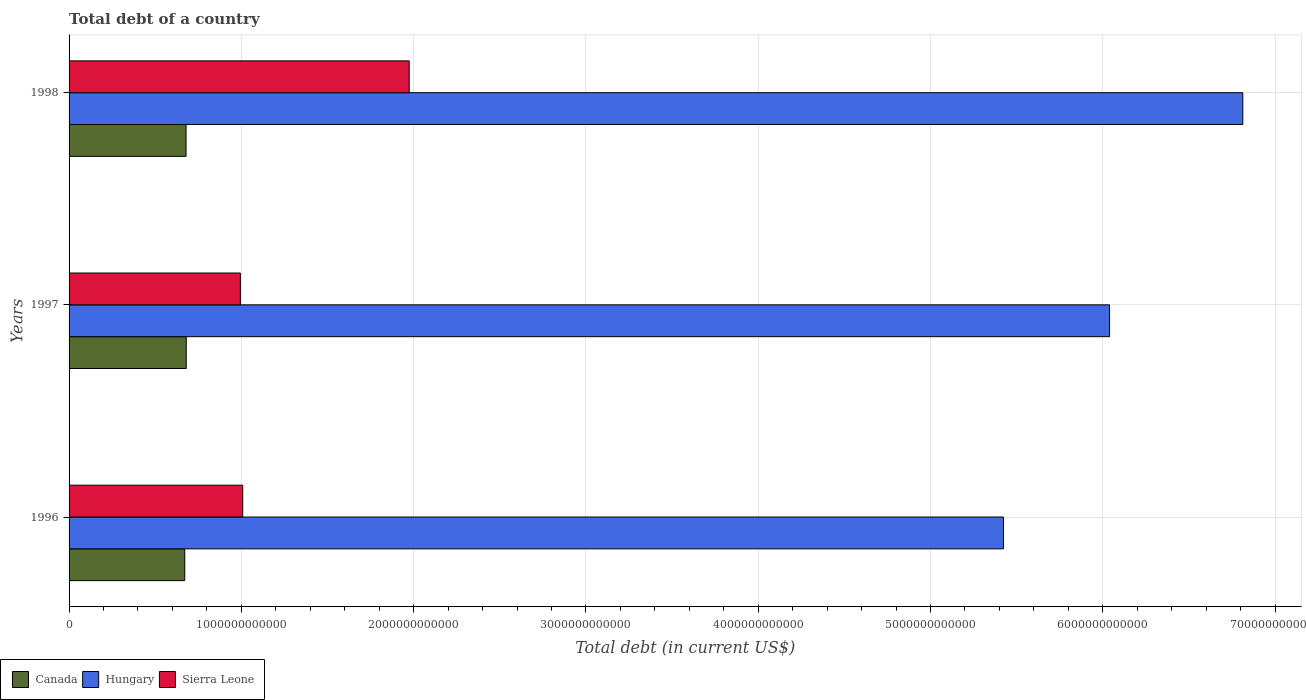How many different coloured bars are there?
Offer a very short reply. 3. Are the number of bars on each tick of the Y-axis equal?
Provide a short and direct response. Yes. How many bars are there on the 2nd tick from the top?
Your answer should be compact. 3. How many bars are there on the 1st tick from the bottom?
Provide a short and direct response. 3. What is the debt in Canada in 1996?
Provide a short and direct response. 6.71e+11. Across all years, what is the maximum debt in Hungary?
Make the answer very short. 6.81e+12. Across all years, what is the minimum debt in Hungary?
Offer a terse response. 5.42e+12. What is the total debt in Canada in the graph?
Make the answer very short. 2.03e+12. What is the difference between the debt in Canada in 1996 and that in 1997?
Provide a succinct answer. -8.71e+09. What is the difference between the debt in Sierra Leone in 1997 and the debt in Canada in 1998?
Keep it short and to the point. 3.15e+11. What is the average debt in Canada per year?
Offer a very short reply. 6.77e+11. In the year 1998, what is the difference between the debt in Canada and debt in Hungary?
Provide a succinct answer. -6.13e+12. What is the ratio of the debt in Hungary in 1996 to that in 1997?
Your answer should be very brief. 0.9. What is the difference between the highest and the second highest debt in Hungary?
Your response must be concise. 7.73e+11. What is the difference between the highest and the lowest debt in Canada?
Your answer should be compact. 8.71e+09. Is the sum of the debt in Hungary in 1996 and 1997 greater than the maximum debt in Canada across all years?
Your answer should be very brief. Yes. What does the 1st bar from the bottom in 1997 represents?
Ensure brevity in your answer.  Canada. How many bars are there?
Make the answer very short. 9. How many years are there in the graph?
Keep it short and to the point. 3. What is the difference between two consecutive major ticks on the X-axis?
Provide a succinct answer. 1.00e+12. Does the graph contain any zero values?
Give a very brief answer. No. What is the title of the graph?
Give a very brief answer. Total debt of a country. What is the label or title of the X-axis?
Offer a terse response. Total debt (in current US$). What is the Total debt (in current US$) of Canada in 1996?
Give a very brief answer. 6.71e+11. What is the Total debt (in current US$) in Hungary in 1996?
Keep it short and to the point. 5.42e+12. What is the Total debt (in current US$) in Sierra Leone in 1996?
Your answer should be compact. 1.01e+12. What is the Total debt (in current US$) in Canada in 1997?
Make the answer very short. 6.80e+11. What is the Total debt (in current US$) of Hungary in 1997?
Give a very brief answer. 6.04e+12. What is the Total debt (in current US$) in Sierra Leone in 1997?
Provide a succinct answer. 9.94e+11. What is the Total debt (in current US$) in Canada in 1998?
Provide a short and direct response. 6.79e+11. What is the Total debt (in current US$) in Hungary in 1998?
Make the answer very short. 6.81e+12. What is the Total debt (in current US$) of Sierra Leone in 1998?
Provide a short and direct response. 1.97e+12. Across all years, what is the maximum Total debt (in current US$) in Canada?
Ensure brevity in your answer.  6.80e+11. Across all years, what is the maximum Total debt (in current US$) in Hungary?
Your answer should be compact. 6.81e+12. Across all years, what is the maximum Total debt (in current US$) of Sierra Leone?
Your answer should be very brief. 1.97e+12. Across all years, what is the minimum Total debt (in current US$) of Canada?
Your answer should be very brief. 6.71e+11. Across all years, what is the minimum Total debt (in current US$) in Hungary?
Offer a terse response. 5.42e+12. Across all years, what is the minimum Total debt (in current US$) in Sierra Leone?
Offer a terse response. 9.94e+11. What is the total Total debt (in current US$) in Canada in the graph?
Offer a terse response. 2.03e+12. What is the total Total debt (in current US$) of Hungary in the graph?
Provide a short and direct response. 1.83e+13. What is the total Total debt (in current US$) in Sierra Leone in the graph?
Offer a terse response. 3.98e+12. What is the difference between the Total debt (in current US$) in Canada in 1996 and that in 1997?
Your answer should be compact. -8.71e+09. What is the difference between the Total debt (in current US$) in Hungary in 1996 and that in 1997?
Your response must be concise. -6.16e+11. What is the difference between the Total debt (in current US$) of Sierra Leone in 1996 and that in 1997?
Your response must be concise. 1.37e+1. What is the difference between the Total debt (in current US$) of Canada in 1996 and that in 1998?
Keep it short and to the point. -7.54e+09. What is the difference between the Total debt (in current US$) of Hungary in 1996 and that in 1998?
Ensure brevity in your answer.  -1.39e+12. What is the difference between the Total debt (in current US$) of Sierra Leone in 1996 and that in 1998?
Offer a terse response. -9.66e+11. What is the difference between the Total debt (in current US$) in Canada in 1997 and that in 1998?
Offer a very short reply. 1.16e+09. What is the difference between the Total debt (in current US$) in Hungary in 1997 and that in 1998?
Ensure brevity in your answer.  -7.73e+11. What is the difference between the Total debt (in current US$) in Sierra Leone in 1997 and that in 1998?
Keep it short and to the point. -9.80e+11. What is the difference between the Total debt (in current US$) of Canada in 1996 and the Total debt (in current US$) of Hungary in 1997?
Provide a succinct answer. -5.37e+12. What is the difference between the Total debt (in current US$) in Canada in 1996 and the Total debt (in current US$) in Sierra Leone in 1997?
Your answer should be very brief. -3.23e+11. What is the difference between the Total debt (in current US$) of Hungary in 1996 and the Total debt (in current US$) of Sierra Leone in 1997?
Ensure brevity in your answer.  4.43e+12. What is the difference between the Total debt (in current US$) in Canada in 1996 and the Total debt (in current US$) in Hungary in 1998?
Provide a succinct answer. -6.14e+12. What is the difference between the Total debt (in current US$) of Canada in 1996 and the Total debt (in current US$) of Sierra Leone in 1998?
Ensure brevity in your answer.  -1.30e+12. What is the difference between the Total debt (in current US$) of Hungary in 1996 and the Total debt (in current US$) of Sierra Leone in 1998?
Your answer should be very brief. 3.45e+12. What is the difference between the Total debt (in current US$) in Canada in 1997 and the Total debt (in current US$) in Hungary in 1998?
Your response must be concise. -6.13e+12. What is the difference between the Total debt (in current US$) in Canada in 1997 and the Total debt (in current US$) in Sierra Leone in 1998?
Offer a very short reply. -1.29e+12. What is the difference between the Total debt (in current US$) in Hungary in 1997 and the Total debt (in current US$) in Sierra Leone in 1998?
Your response must be concise. 4.07e+12. What is the average Total debt (in current US$) of Canada per year?
Offer a very short reply. 6.77e+11. What is the average Total debt (in current US$) of Hungary per year?
Give a very brief answer. 6.09e+12. What is the average Total debt (in current US$) in Sierra Leone per year?
Your response must be concise. 1.33e+12. In the year 1996, what is the difference between the Total debt (in current US$) of Canada and Total debt (in current US$) of Hungary?
Your answer should be compact. -4.75e+12. In the year 1996, what is the difference between the Total debt (in current US$) of Canada and Total debt (in current US$) of Sierra Leone?
Give a very brief answer. -3.37e+11. In the year 1996, what is the difference between the Total debt (in current US$) in Hungary and Total debt (in current US$) in Sierra Leone?
Your answer should be compact. 4.42e+12. In the year 1997, what is the difference between the Total debt (in current US$) of Canada and Total debt (in current US$) of Hungary?
Provide a short and direct response. -5.36e+12. In the year 1997, what is the difference between the Total debt (in current US$) of Canada and Total debt (in current US$) of Sierra Leone?
Provide a succinct answer. -3.14e+11. In the year 1997, what is the difference between the Total debt (in current US$) in Hungary and Total debt (in current US$) in Sierra Leone?
Offer a very short reply. 5.05e+12. In the year 1998, what is the difference between the Total debt (in current US$) in Canada and Total debt (in current US$) in Hungary?
Your response must be concise. -6.13e+12. In the year 1998, what is the difference between the Total debt (in current US$) of Canada and Total debt (in current US$) of Sierra Leone?
Provide a short and direct response. -1.30e+12. In the year 1998, what is the difference between the Total debt (in current US$) of Hungary and Total debt (in current US$) of Sierra Leone?
Your response must be concise. 4.84e+12. What is the ratio of the Total debt (in current US$) of Canada in 1996 to that in 1997?
Ensure brevity in your answer.  0.99. What is the ratio of the Total debt (in current US$) of Hungary in 1996 to that in 1997?
Your answer should be compact. 0.9. What is the ratio of the Total debt (in current US$) in Sierra Leone in 1996 to that in 1997?
Offer a very short reply. 1.01. What is the ratio of the Total debt (in current US$) of Canada in 1996 to that in 1998?
Make the answer very short. 0.99. What is the ratio of the Total debt (in current US$) of Hungary in 1996 to that in 1998?
Provide a short and direct response. 0.8. What is the ratio of the Total debt (in current US$) in Sierra Leone in 1996 to that in 1998?
Make the answer very short. 0.51. What is the ratio of the Total debt (in current US$) of Hungary in 1997 to that in 1998?
Give a very brief answer. 0.89. What is the ratio of the Total debt (in current US$) in Sierra Leone in 1997 to that in 1998?
Keep it short and to the point. 0.5. What is the difference between the highest and the second highest Total debt (in current US$) of Canada?
Make the answer very short. 1.16e+09. What is the difference between the highest and the second highest Total debt (in current US$) of Hungary?
Provide a succinct answer. 7.73e+11. What is the difference between the highest and the second highest Total debt (in current US$) of Sierra Leone?
Offer a very short reply. 9.66e+11. What is the difference between the highest and the lowest Total debt (in current US$) in Canada?
Offer a terse response. 8.71e+09. What is the difference between the highest and the lowest Total debt (in current US$) in Hungary?
Keep it short and to the point. 1.39e+12. What is the difference between the highest and the lowest Total debt (in current US$) of Sierra Leone?
Your answer should be compact. 9.80e+11. 